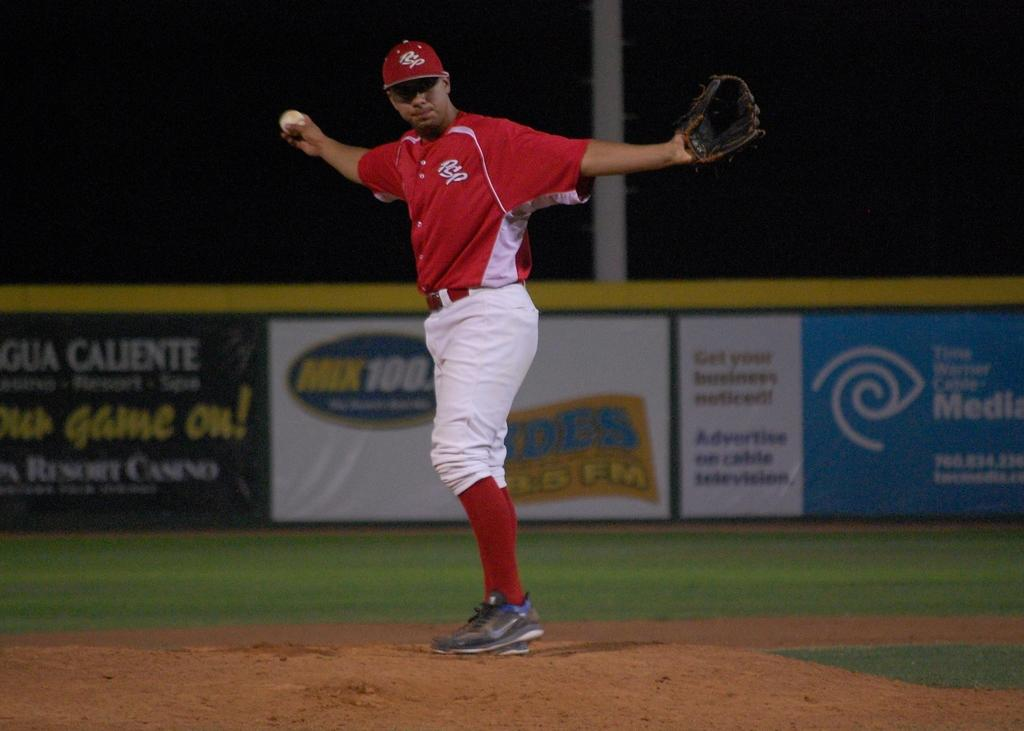<image>
Relay a brief, clear account of the picture shown. A man in a red and white baseball uniform in front of a Timer Warner Cable ad. 